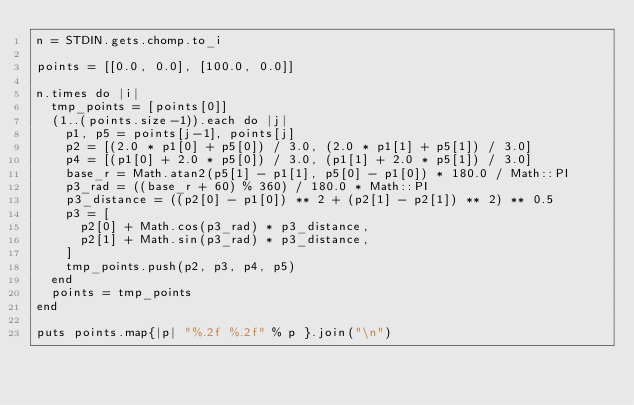Convert code to text. <code><loc_0><loc_0><loc_500><loc_500><_Ruby_>n = STDIN.gets.chomp.to_i

points = [[0.0, 0.0], [100.0, 0.0]]

n.times do |i|
  tmp_points = [points[0]]
  (1..(points.size-1)).each do |j|
    p1, p5 = points[j-1], points[j]
    p2 = [(2.0 * p1[0] + p5[0]) / 3.0, (2.0 * p1[1] + p5[1]) / 3.0]
    p4 = [(p1[0] + 2.0 * p5[0]) / 3.0, (p1[1] + 2.0 * p5[1]) / 3.0]
    base_r = Math.atan2(p5[1] - p1[1], p5[0] - p1[0]) * 180.0 / Math::PI
    p3_rad = ((base_r + 60) % 360) / 180.0 * Math::PI
    p3_distance = ((p2[0] - p1[0]) ** 2 + (p2[1] - p2[1]) ** 2) ** 0.5
    p3 = [
      p2[0] + Math.cos(p3_rad) * p3_distance,
      p2[1] + Math.sin(p3_rad) * p3_distance,
    ]
    tmp_points.push(p2, p3, p4, p5)
  end
  points = tmp_points
end

puts points.map{|p| "%.2f %.2f" % p }.join("\n")</code> 